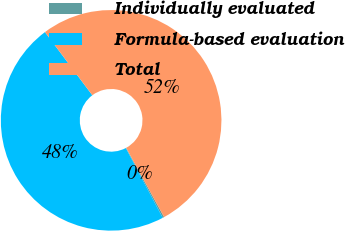<chart> <loc_0><loc_0><loc_500><loc_500><pie_chart><fcel>Individually evaluated<fcel>Formula-based evaluation<fcel>Total<nl><fcel>0.23%<fcel>47.51%<fcel>52.26%<nl></chart> 